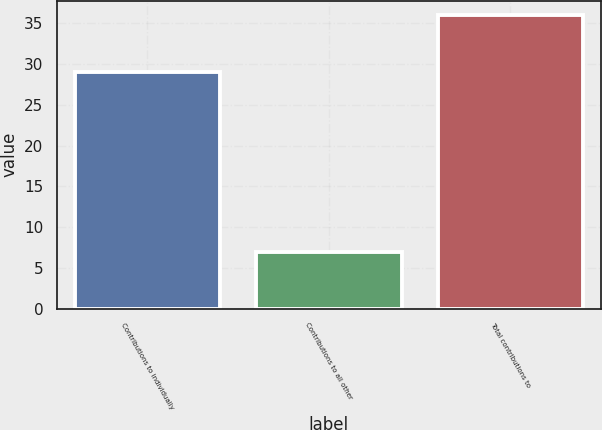Convert chart. <chart><loc_0><loc_0><loc_500><loc_500><bar_chart><fcel>Contributions to individually<fcel>Contributions to all other<fcel>Total contributions to<nl><fcel>29<fcel>7<fcel>36<nl></chart> 